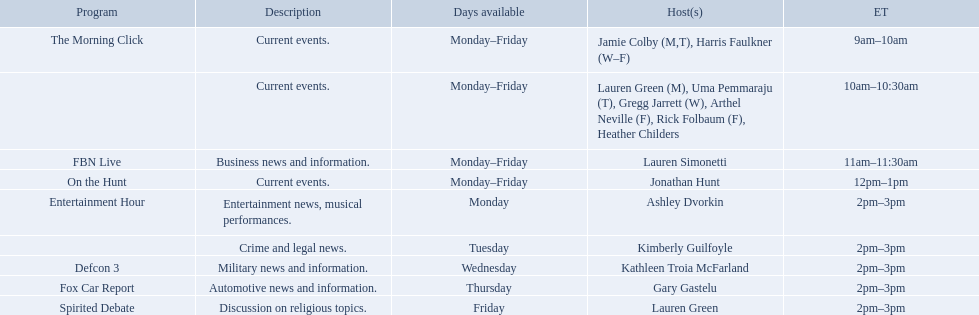Who are all of the hosts? Jamie Colby (M,T), Harris Faulkner (W–F), Lauren Green (M), Uma Pemmaraju (T), Gregg Jarrett (W), Arthel Neville (F), Rick Folbaum (F), Heather Childers, Lauren Simonetti, Jonathan Hunt, Ashley Dvorkin, Kimberly Guilfoyle, Kathleen Troia McFarland, Gary Gastelu, Lauren Green. Which hosts have shows on fridays? Jamie Colby (M,T), Harris Faulkner (W–F), Lauren Green (M), Uma Pemmaraju (T), Gregg Jarrett (W), Arthel Neville (F), Rick Folbaum (F), Heather Childers, Lauren Simonetti, Jonathan Hunt, Lauren Green. Of those, which host's show airs at 2pm? Lauren Green. 